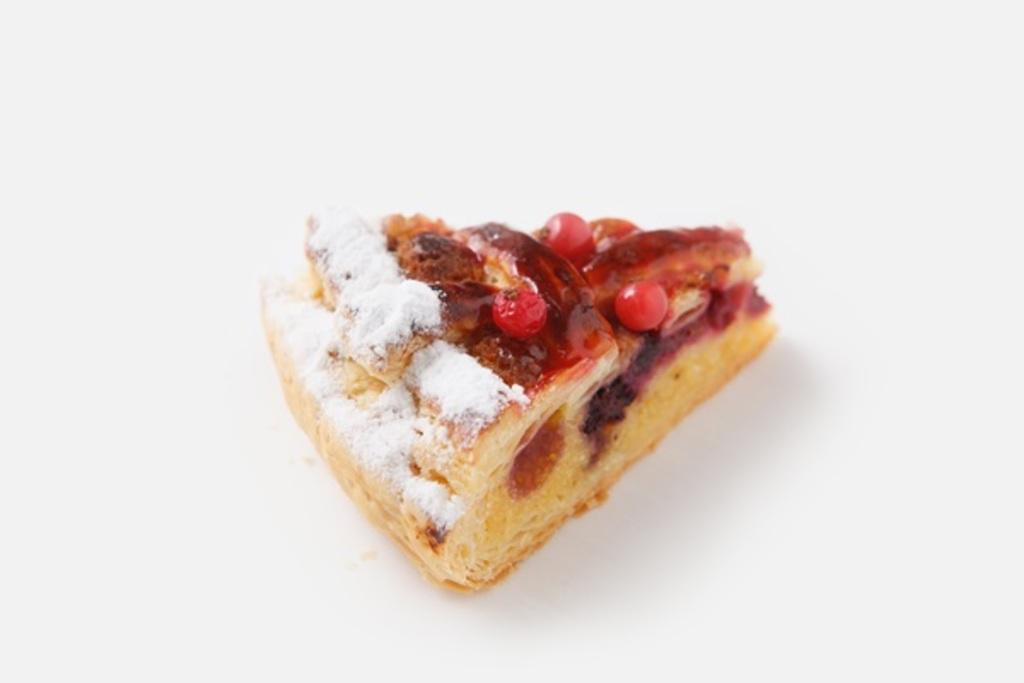What type of food is visible in the image? There is a piece of fruit bread in the image. What is on top of the fruit bread? The fruit bread is topped with fruits. Where is the fruit bread placed? The fruit bread is placed on a surface. What type of poison is visible on the fruit bread in the image? There is no poison present on the fruit bread in the image. 